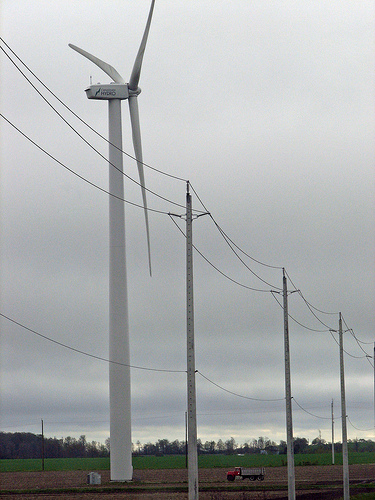<image>
Is the wind turbine in front of the power line? No. The wind turbine is not in front of the power line. The spatial positioning shows a different relationship between these objects. 